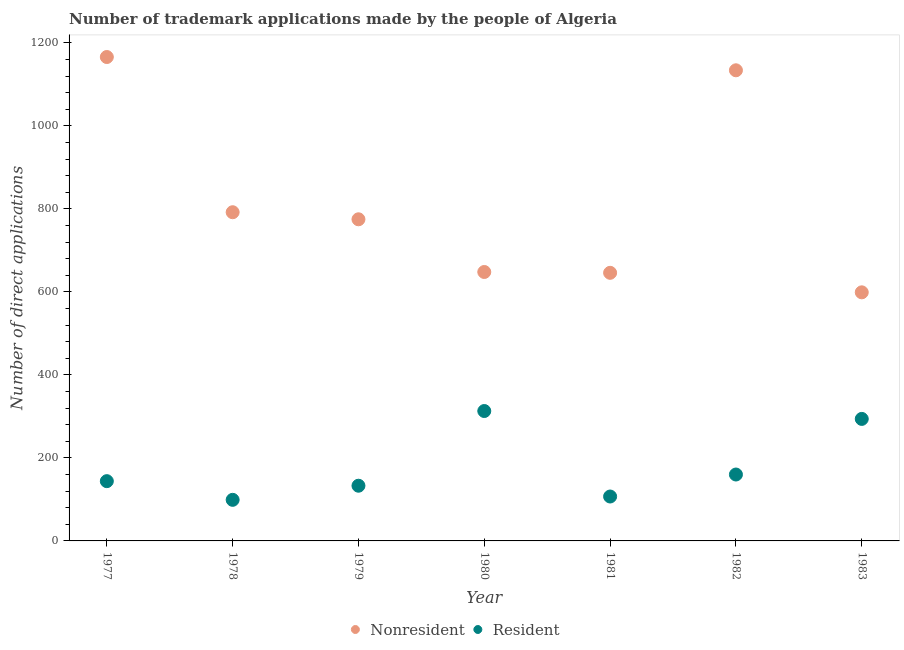Is the number of dotlines equal to the number of legend labels?
Make the answer very short. Yes. What is the number of trademark applications made by non residents in 1983?
Provide a short and direct response. 599. Across all years, what is the maximum number of trademark applications made by non residents?
Provide a short and direct response. 1166. Across all years, what is the minimum number of trademark applications made by non residents?
Ensure brevity in your answer.  599. In which year was the number of trademark applications made by non residents maximum?
Your response must be concise. 1977. In which year was the number of trademark applications made by residents minimum?
Provide a short and direct response. 1978. What is the total number of trademark applications made by residents in the graph?
Your response must be concise. 1250. What is the difference between the number of trademark applications made by residents in 1978 and that in 1981?
Your response must be concise. -8. What is the difference between the number of trademark applications made by residents in 1981 and the number of trademark applications made by non residents in 1983?
Provide a short and direct response. -492. What is the average number of trademark applications made by residents per year?
Make the answer very short. 178.57. In the year 1979, what is the difference between the number of trademark applications made by non residents and number of trademark applications made by residents?
Your response must be concise. 642. What is the ratio of the number of trademark applications made by non residents in 1977 to that in 1979?
Provide a succinct answer. 1.5. Is the number of trademark applications made by non residents in 1980 less than that in 1983?
Provide a succinct answer. No. What is the difference between the highest and the second highest number of trademark applications made by non residents?
Offer a very short reply. 32. What is the difference between the highest and the lowest number of trademark applications made by non residents?
Your answer should be very brief. 567. In how many years, is the number of trademark applications made by non residents greater than the average number of trademark applications made by non residents taken over all years?
Offer a very short reply. 2. Is the sum of the number of trademark applications made by residents in 1977 and 1979 greater than the maximum number of trademark applications made by non residents across all years?
Provide a succinct answer. No. Is the number of trademark applications made by residents strictly greater than the number of trademark applications made by non residents over the years?
Keep it short and to the point. No. Is the number of trademark applications made by residents strictly less than the number of trademark applications made by non residents over the years?
Provide a short and direct response. Yes. How many dotlines are there?
Provide a short and direct response. 2. How many years are there in the graph?
Your response must be concise. 7. What is the difference between two consecutive major ticks on the Y-axis?
Your response must be concise. 200. Does the graph contain any zero values?
Your answer should be compact. No. Where does the legend appear in the graph?
Make the answer very short. Bottom center. How are the legend labels stacked?
Keep it short and to the point. Horizontal. What is the title of the graph?
Offer a terse response. Number of trademark applications made by the people of Algeria. Does "Passenger Transport Items" appear as one of the legend labels in the graph?
Provide a short and direct response. No. What is the label or title of the X-axis?
Offer a terse response. Year. What is the label or title of the Y-axis?
Make the answer very short. Number of direct applications. What is the Number of direct applications of Nonresident in 1977?
Your answer should be very brief. 1166. What is the Number of direct applications of Resident in 1977?
Provide a succinct answer. 144. What is the Number of direct applications of Nonresident in 1978?
Offer a very short reply. 792. What is the Number of direct applications of Nonresident in 1979?
Make the answer very short. 775. What is the Number of direct applications in Resident in 1979?
Offer a very short reply. 133. What is the Number of direct applications of Nonresident in 1980?
Your response must be concise. 648. What is the Number of direct applications in Resident in 1980?
Offer a very short reply. 313. What is the Number of direct applications in Nonresident in 1981?
Provide a succinct answer. 646. What is the Number of direct applications of Resident in 1981?
Ensure brevity in your answer.  107. What is the Number of direct applications in Nonresident in 1982?
Offer a very short reply. 1134. What is the Number of direct applications of Resident in 1982?
Provide a succinct answer. 160. What is the Number of direct applications in Nonresident in 1983?
Offer a terse response. 599. What is the Number of direct applications of Resident in 1983?
Keep it short and to the point. 294. Across all years, what is the maximum Number of direct applications in Nonresident?
Your response must be concise. 1166. Across all years, what is the maximum Number of direct applications of Resident?
Your response must be concise. 313. Across all years, what is the minimum Number of direct applications in Nonresident?
Your answer should be compact. 599. What is the total Number of direct applications of Nonresident in the graph?
Give a very brief answer. 5760. What is the total Number of direct applications in Resident in the graph?
Provide a succinct answer. 1250. What is the difference between the Number of direct applications of Nonresident in 1977 and that in 1978?
Offer a very short reply. 374. What is the difference between the Number of direct applications of Nonresident in 1977 and that in 1979?
Make the answer very short. 391. What is the difference between the Number of direct applications of Nonresident in 1977 and that in 1980?
Give a very brief answer. 518. What is the difference between the Number of direct applications of Resident in 1977 and that in 1980?
Keep it short and to the point. -169. What is the difference between the Number of direct applications of Nonresident in 1977 and that in 1981?
Your answer should be compact. 520. What is the difference between the Number of direct applications of Resident in 1977 and that in 1981?
Ensure brevity in your answer.  37. What is the difference between the Number of direct applications in Nonresident in 1977 and that in 1982?
Provide a succinct answer. 32. What is the difference between the Number of direct applications of Nonresident in 1977 and that in 1983?
Your answer should be compact. 567. What is the difference between the Number of direct applications of Resident in 1977 and that in 1983?
Give a very brief answer. -150. What is the difference between the Number of direct applications of Resident in 1978 and that in 1979?
Make the answer very short. -34. What is the difference between the Number of direct applications of Nonresident in 1978 and that in 1980?
Ensure brevity in your answer.  144. What is the difference between the Number of direct applications in Resident in 1978 and that in 1980?
Your answer should be compact. -214. What is the difference between the Number of direct applications of Nonresident in 1978 and that in 1981?
Provide a succinct answer. 146. What is the difference between the Number of direct applications in Resident in 1978 and that in 1981?
Keep it short and to the point. -8. What is the difference between the Number of direct applications of Nonresident in 1978 and that in 1982?
Your response must be concise. -342. What is the difference between the Number of direct applications of Resident in 1978 and that in 1982?
Offer a very short reply. -61. What is the difference between the Number of direct applications in Nonresident in 1978 and that in 1983?
Provide a succinct answer. 193. What is the difference between the Number of direct applications in Resident in 1978 and that in 1983?
Your response must be concise. -195. What is the difference between the Number of direct applications in Nonresident in 1979 and that in 1980?
Give a very brief answer. 127. What is the difference between the Number of direct applications of Resident in 1979 and that in 1980?
Your response must be concise. -180. What is the difference between the Number of direct applications in Nonresident in 1979 and that in 1981?
Give a very brief answer. 129. What is the difference between the Number of direct applications in Nonresident in 1979 and that in 1982?
Provide a succinct answer. -359. What is the difference between the Number of direct applications of Nonresident in 1979 and that in 1983?
Ensure brevity in your answer.  176. What is the difference between the Number of direct applications of Resident in 1979 and that in 1983?
Offer a very short reply. -161. What is the difference between the Number of direct applications of Resident in 1980 and that in 1981?
Your response must be concise. 206. What is the difference between the Number of direct applications of Nonresident in 1980 and that in 1982?
Your answer should be very brief. -486. What is the difference between the Number of direct applications in Resident in 1980 and that in 1982?
Your response must be concise. 153. What is the difference between the Number of direct applications in Nonresident in 1981 and that in 1982?
Your answer should be very brief. -488. What is the difference between the Number of direct applications in Resident in 1981 and that in 1982?
Give a very brief answer. -53. What is the difference between the Number of direct applications of Resident in 1981 and that in 1983?
Give a very brief answer. -187. What is the difference between the Number of direct applications in Nonresident in 1982 and that in 1983?
Your answer should be very brief. 535. What is the difference between the Number of direct applications of Resident in 1982 and that in 1983?
Ensure brevity in your answer.  -134. What is the difference between the Number of direct applications in Nonresident in 1977 and the Number of direct applications in Resident in 1978?
Your answer should be very brief. 1067. What is the difference between the Number of direct applications of Nonresident in 1977 and the Number of direct applications of Resident in 1979?
Your response must be concise. 1033. What is the difference between the Number of direct applications of Nonresident in 1977 and the Number of direct applications of Resident in 1980?
Ensure brevity in your answer.  853. What is the difference between the Number of direct applications of Nonresident in 1977 and the Number of direct applications of Resident in 1981?
Provide a succinct answer. 1059. What is the difference between the Number of direct applications of Nonresident in 1977 and the Number of direct applications of Resident in 1982?
Provide a short and direct response. 1006. What is the difference between the Number of direct applications of Nonresident in 1977 and the Number of direct applications of Resident in 1983?
Offer a terse response. 872. What is the difference between the Number of direct applications of Nonresident in 1978 and the Number of direct applications of Resident in 1979?
Offer a terse response. 659. What is the difference between the Number of direct applications of Nonresident in 1978 and the Number of direct applications of Resident in 1980?
Your response must be concise. 479. What is the difference between the Number of direct applications of Nonresident in 1978 and the Number of direct applications of Resident in 1981?
Your answer should be very brief. 685. What is the difference between the Number of direct applications in Nonresident in 1978 and the Number of direct applications in Resident in 1982?
Provide a succinct answer. 632. What is the difference between the Number of direct applications of Nonresident in 1978 and the Number of direct applications of Resident in 1983?
Give a very brief answer. 498. What is the difference between the Number of direct applications of Nonresident in 1979 and the Number of direct applications of Resident in 1980?
Keep it short and to the point. 462. What is the difference between the Number of direct applications in Nonresident in 1979 and the Number of direct applications in Resident in 1981?
Your response must be concise. 668. What is the difference between the Number of direct applications in Nonresident in 1979 and the Number of direct applications in Resident in 1982?
Offer a terse response. 615. What is the difference between the Number of direct applications in Nonresident in 1979 and the Number of direct applications in Resident in 1983?
Ensure brevity in your answer.  481. What is the difference between the Number of direct applications in Nonresident in 1980 and the Number of direct applications in Resident in 1981?
Make the answer very short. 541. What is the difference between the Number of direct applications of Nonresident in 1980 and the Number of direct applications of Resident in 1982?
Offer a very short reply. 488. What is the difference between the Number of direct applications in Nonresident in 1980 and the Number of direct applications in Resident in 1983?
Your answer should be very brief. 354. What is the difference between the Number of direct applications of Nonresident in 1981 and the Number of direct applications of Resident in 1982?
Offer a terse response. 486. What is the difference between the Number of direct applications of Nonresident in 1981 and the Number of direct applications of Resident in 1983?
Provide a short and direct response. 352. What is the difference between the Number of direct applications in Nonresident in 1982 and the Number of direct applications in Resident in 1983?
Offer a very short reply. 840. What is the average Number of direct applications of Nonresident per year?
Your answer should be compact. 822.86. What is the average Number of direct applications in Resident per year?
Ensure brevity in your answer.  178.57. In the year 1977, what is the difference between the Number of direct applications in Nonresident and Number of direct applications in Resident?
Provide a succinct answer. 1022. In the year 1978, what is the difference between the Number of direct applications in Nonresident and Number of direct applications in Resident?
Your response must be concise. 693. In the year 1979, what is the difference between the Number of direct applications of Nonresident and Number of direct applications of Resident?
Your response must be concise. 642. In the year 1980, what is the difference between the Number of direct applications of Nonresident and Number of direct applications of Resident?
Offer a very short reply. 335. In the year 1981, what is the difference between the Number of direct applications of Nonresident and Number of direct applications of Resident?
Provide a short and direct response. 539. In the year 1982, what is the difference between the Number of direct applications in Nonresident and Number of direct applications in Resident?
Your response must be concise. 974. In the year 1983, what is the difference between the Number of direct applications of Nonresident and Number of direct applications of Resident?
Provide a succinct answer. 305. What is the ratio of the Number of direct applications in Nonresident in 1977 to that in 1978?
Your response must be concise. 1.47. What is the ratio of the Number of direct applications of Resident in 1977 to that in 1978?
Give a very brief answer. 1.45. What is the ratio of the Number of direct applications of Nonresident in 1977 to that in 1979?
Your answer should be compact. 1.5. What is the ratio of the Number of direct applications in Resident in 1977 to that in 1979?
Make the answer very short. 1.08. What is the ratio of the Number of direct applications of Nonresident in 1977 to that in 1980?
Your answer should be very brief. 1.8. What is the ratio of the Number of direct applications of Resident in 1977 to that in 1980?
Provide a short and direct response. 0.46. What is the ratio of the Number of direct applications in Nonresident in 1977 to that in 1981?
Your response must be concise. 1.8. What is the ratio of the Number of direct applications of Resident in 1977 to that in 1981?
Provide a succinct answer. 1.35. What is the ratio of the Number of direct applications in Nonresident in 1977 to that in 1982?
Give a very brief answer. 1.03. What is the ratio of the Number of direct applications in Resident in 1977 to that in 1982?
Make the answer very short. 0.9. What is the ratio of the Number of direct applications in Nonresident in 1977 to that in 1983?
Your response must be concise. 1.95. What is the ratio of the Number of direct applications in Resident in 1977 to that in 1983?
Keep it short and to the point. 0.49. What is the ratio of the Number of direct applications in Nonresident in 1978 to that in 1979?
Give a very brief answer. 1.02. What is the ratio of the Number of direct applications in Resident in 1978 to that in 1979?
Give a very brief answer. 0.74. What is the ratio of the Number of direct applications of Nonresident in 1978 to that in 1980?
Make the answer very short. 1.22. What is the ratio of the Number of direct applications in Resident in 1978 to that in 1980?
Provide a short and direct response. 0.32. What is the ratio of the Number of direct applications of Nonresident in 1978 to that in 1981?
Your answer should be compact. 1.23. What is the ratio of the Number of direct applications in Resident in 1978 to that in 1981?
Your answer should be very brief. 0.93. What is the ratio of the Number of direct applications in Nonresident in 1978 to that in 1982?
Give a very brief answer. 0.7. What is the ratio of the Number of direct applications in Resident in 1978 to that in 1982?
Offer a very short reply. 0.62. What is the ratio of the Number of direct applications of Nonresident in 1978 to that in 1983?
Make the answer very short. 1.32. What is the ratio of the Number of direct applications in Resident in 1978 to that in 1983?
Give a very brief answer. 0.34. What is the ratio of the Number of direct applications of Nonresident in 1979 to that in 1980?
Provide a short and direct response. 1.2. What is the ratio of the Number of direct applications in Resident in 1979 to that in 1980?
Ensure brevity in your answer.  0.42. What is the ratio of the Number of direct applications of Nonresident in 1979 to that in 1981?
Your response must be concise. 1.2. What is the ratio of the Number of direct applications in Resident in 1979 to that in 1981?
Make the answer very short. 1.24. What is the ratio of the Number of direct applications of Nonresident in 1979 to that in 1982?
Make the answer very short. 0.68. What is the ratio of the Number of direct applications of Resident in 1979 to that in 1982?
Your answer should be very brief. 0.83. What is the ratio of the Number of direct applications in Nonresident in 1979 to that in 1983?
Ensure brevity in your answer.  1.29. What is the ratio of the Number of direct applications of Resident in 1979 to that in 1983?
Your answer should be compact. 0.45. What is the ratio of the Number of direct applications in Nonresident in 1980 to that in 1981?
Provide a short and direct response. 1. What is the ratio of the Number of direct applications of Resident in 1980 to that in 1981?
Provide a succinct answer. 2.93. What is the ratio of the Number of direct applications in Resident in 1980 to that in 1982?
Your answer should be very brief. 1.96. What is the ratio of the Number of direct applications of Nonresident in 1980 to that in 1983?
Your response must be concise. 1.08. What is the ratio of the Number of direct applications in Resident in 1980 to that in 1983?
Provide a succinct answer. 1.06. What is the ratio of the Number of direct applications in Nonresident in 1981 to that in 1982?
Ensure brevity in your answer.  0.57. What is the ratio of the Number of direct applications of Resident in 1981 to that in 1982?
Offer a very short reply. 0.67. What is the ratio of the Number of direct applications in Nonresident in 1981 to that in 1983?
Make the answer very short. 1.08. What is the ratio of the Number of direct applications of Resident in 1981 to that in 1983?
Your answer should be compact. 0.36. What is the ratio of the Number of direct applications in Nonresident in 1982 to that in 1983?
Provide a succinct answer. 1.89. What is the ratio of the Number of direct applications of Resident in 1982 to that in 1983?
Provide a short and direct response. 0.54. What is the difference between the highest and the second highest Number of direct applications in Resident?
Keep it short and to the point. 19. What is the difference between the highest and the lowest Number of direct applications in Nonresident?
Offer a terse response. 567. What is the difference between the highest and the lowest Number of direct applications of Resident?
Provide a short and direct response. 214. 